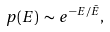Convert formula to latex. <formula><loc_0><loc_0><loc_500><loc_500>p ( E ) \, \sim \, e ^ { - E / \bar { E } } ,</formula> 